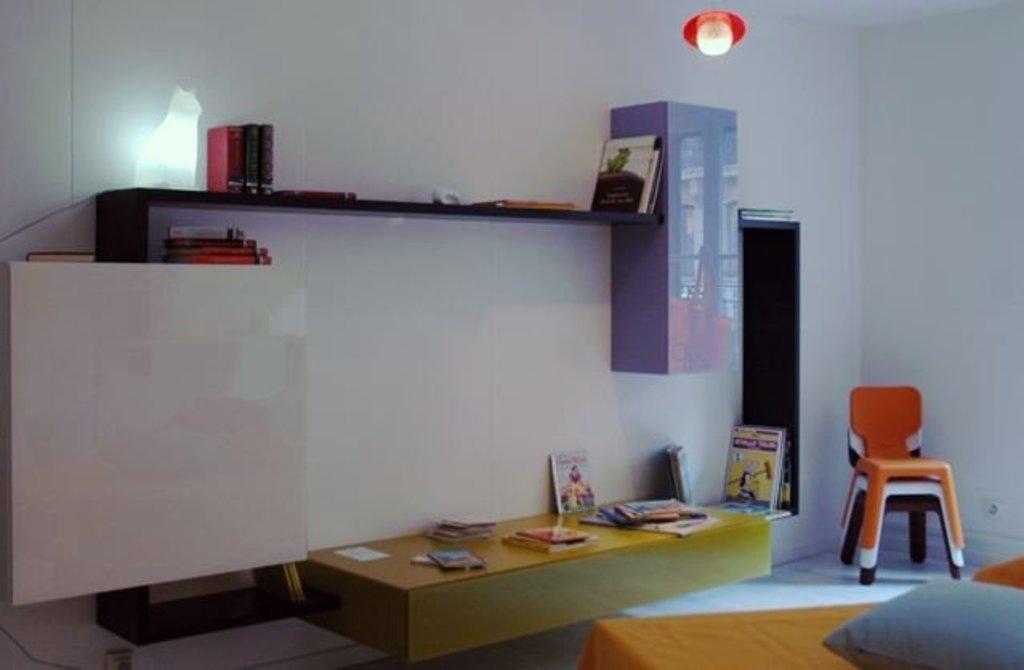Please provide a concise description of this image. In this image we can see a pillow, chairs, cloth, books, rack, table, and few objects. In the background we can see wall and a light. 